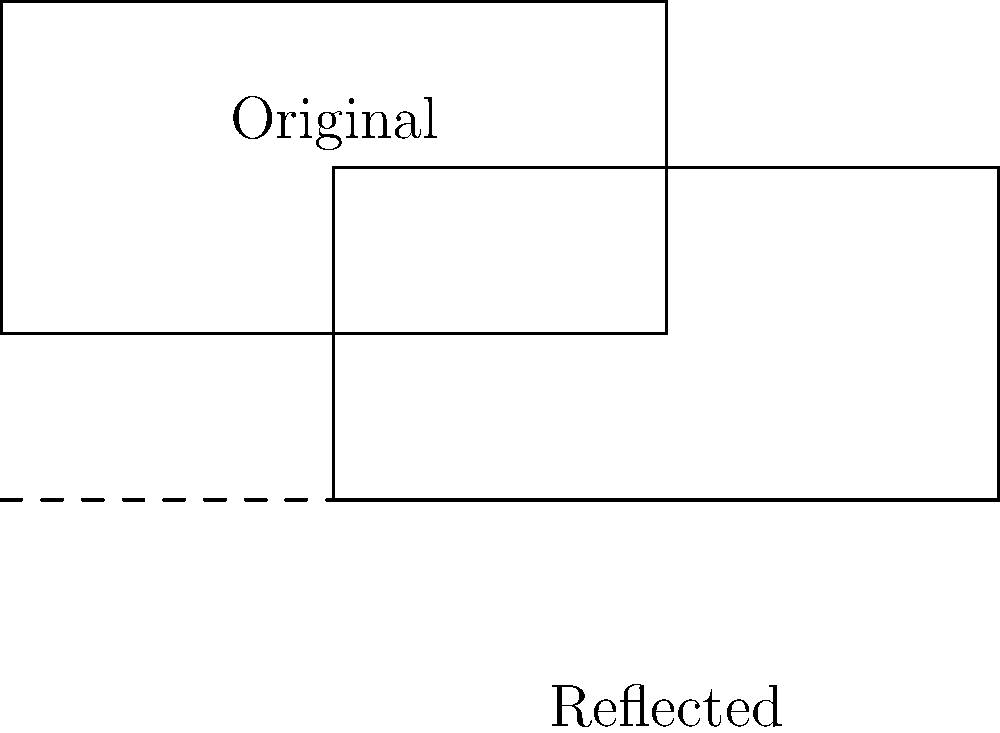A yoga mat is represented by a rectangle in the diagram. If the mat is reflected across the dashed line, what will be the coordinates of point C after the reflection? To find the coordinates of point C after reflection, we need to follow these steps:

1. Identify the original coordinates of point C: $(4,2)$

2. Determine the equation of the line of reflection:
   The dashed line is horizontal and passes through $y=-1$, so its equation is $y=-1$

3. Calculate the distance from point C to the line of reflection:
   Distance = $2 - (-1) = 3$

4. Reflect point C across the line:
   - The x-coordinate remains the same: $x=4$
   - The y-coordinate will be the same distance below the line as it was above:
     New y-coordinate = $-1 - 3 = -4$

5. Therefore, the coordinates of point C after reflection are $(4,-4)$
Answer: $(4,-4)$ 